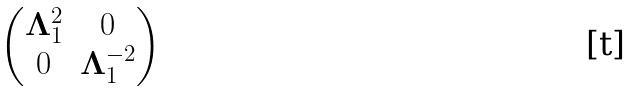Convert formula to latex. <formula><loc_0><loc_0><loc_500><loc_500>\begin{pmatrix} { \mathbf \Lambda } _ { 1 } ^ { 2 } & 0 \\ 0 & { \mathbf \Lambda } _ { 1 } ^ { - 2 } \\ \end{pmatrix}</formula> 